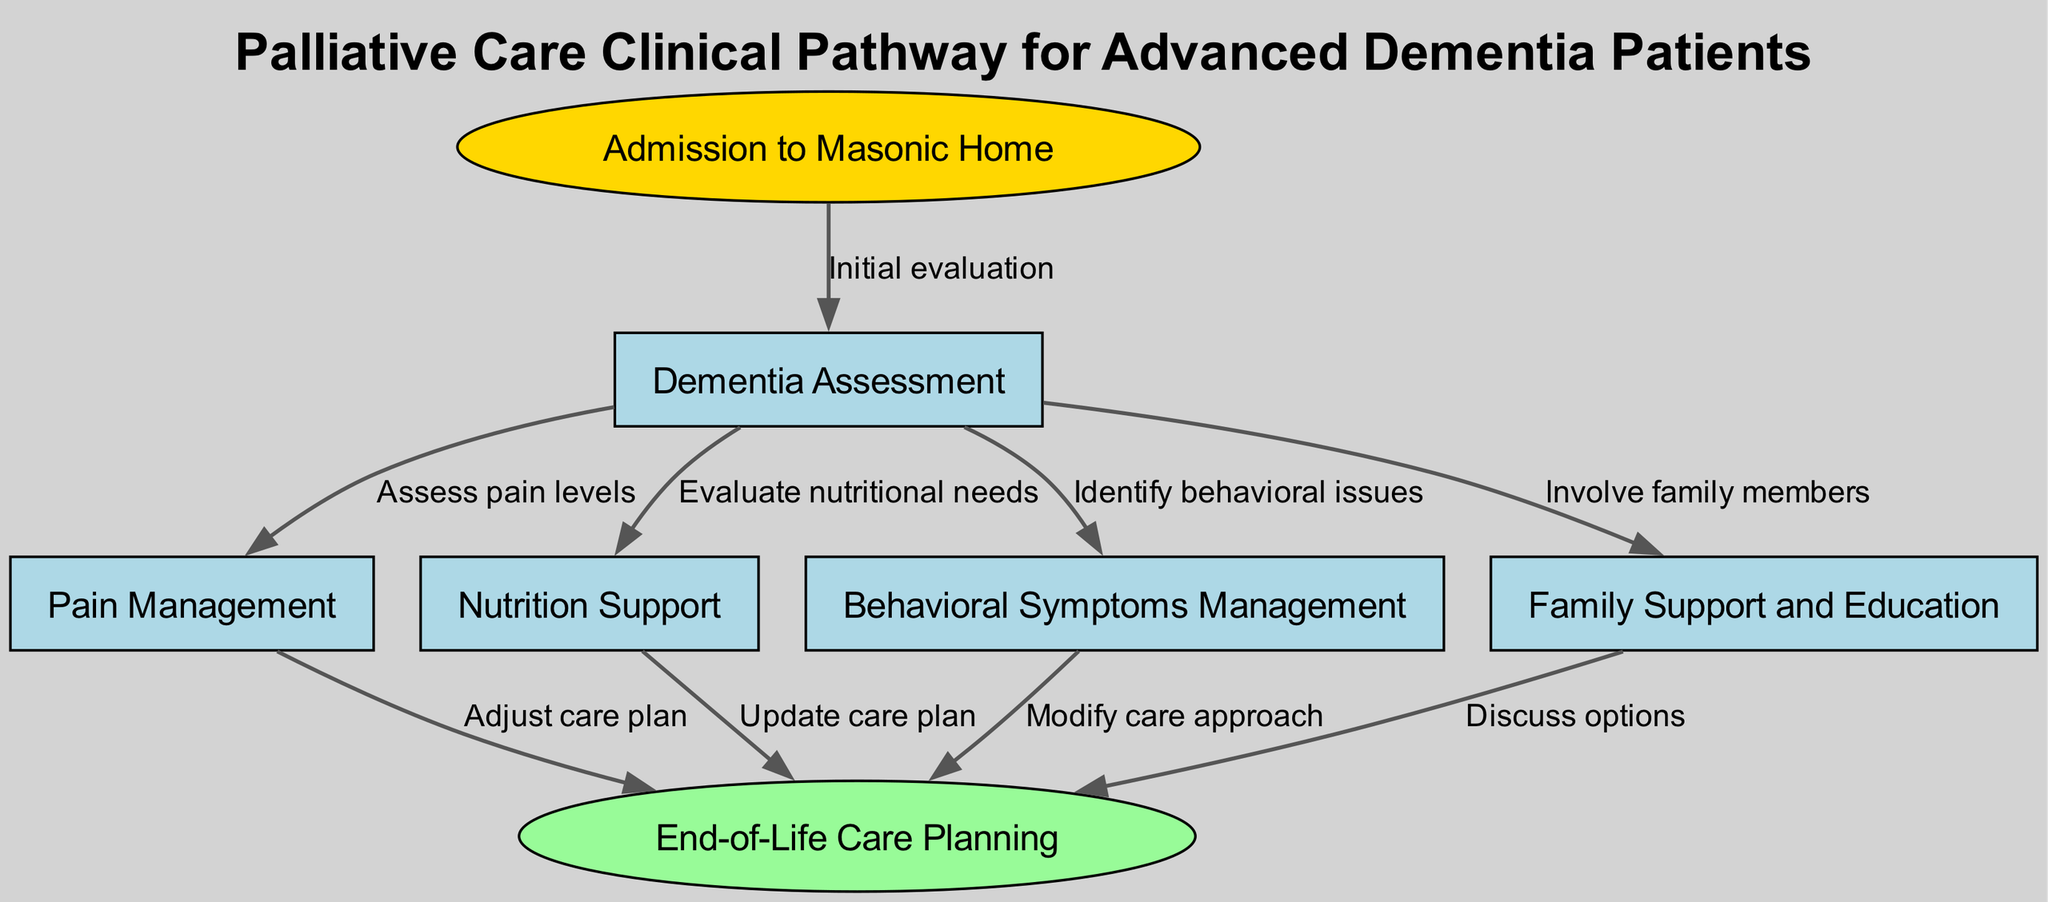What is the first step in the clinical pathway? The first step is "Admission to Masonic Home," which is the starting point of the pathway, indicated by the initial node.
Answer: Admission to Masonic Home How many nodes are present in the diagram? By counting each unique labeled section in the diagram, there are 7 nodes depicted, representing various stages in the clinical pathway.
Answer: 7 What is the last step indicated in the pathway? The last step is "End-of-Life Care Planning," which is represented as the terminal node, showing a critical phase in patient care.
Answer: End-of-Life Care Planning Which node involves family members? The node labeled "Family Support and Education" explicitly mentions the involvement of family members in the care process.
Answer: Family Support and Education What are the three management types related to the intermediate nodes? The intermediate nodes relate to "Pain Management," "Nutrition Support," and "Behavioral Symptoms Management," which collectively address key aspects of patient treatment.
Answer: Pain Management, Nutrition Support, Behavioral Symptoms Management How does "Pain Management" lead to "End-of-Life Care Planning"? "Pain Management" connects to "End-of-Life Care Planning" as pain levels assessed guide the adaptation of care plans, ensuring patient comfort in the final stages.
Answer: Adjust care plan What step directly follows "Dementia Assessment" related to "Nutrition Support"? Following "Dementia Assessment," the subsequent step related to "Nutrition Support" is the evaluation of nutritional needs, ensuring proper dietary care is assessed.
Answer: Evaluate nutritional needs Which node modifies care approaches based on behavioral issues? The node "Behavioral Symptoms Management" modifies care approaches in response to identified issues, aiming to create a tailored treatment strategy for patients.
Answer: Modify care approach 